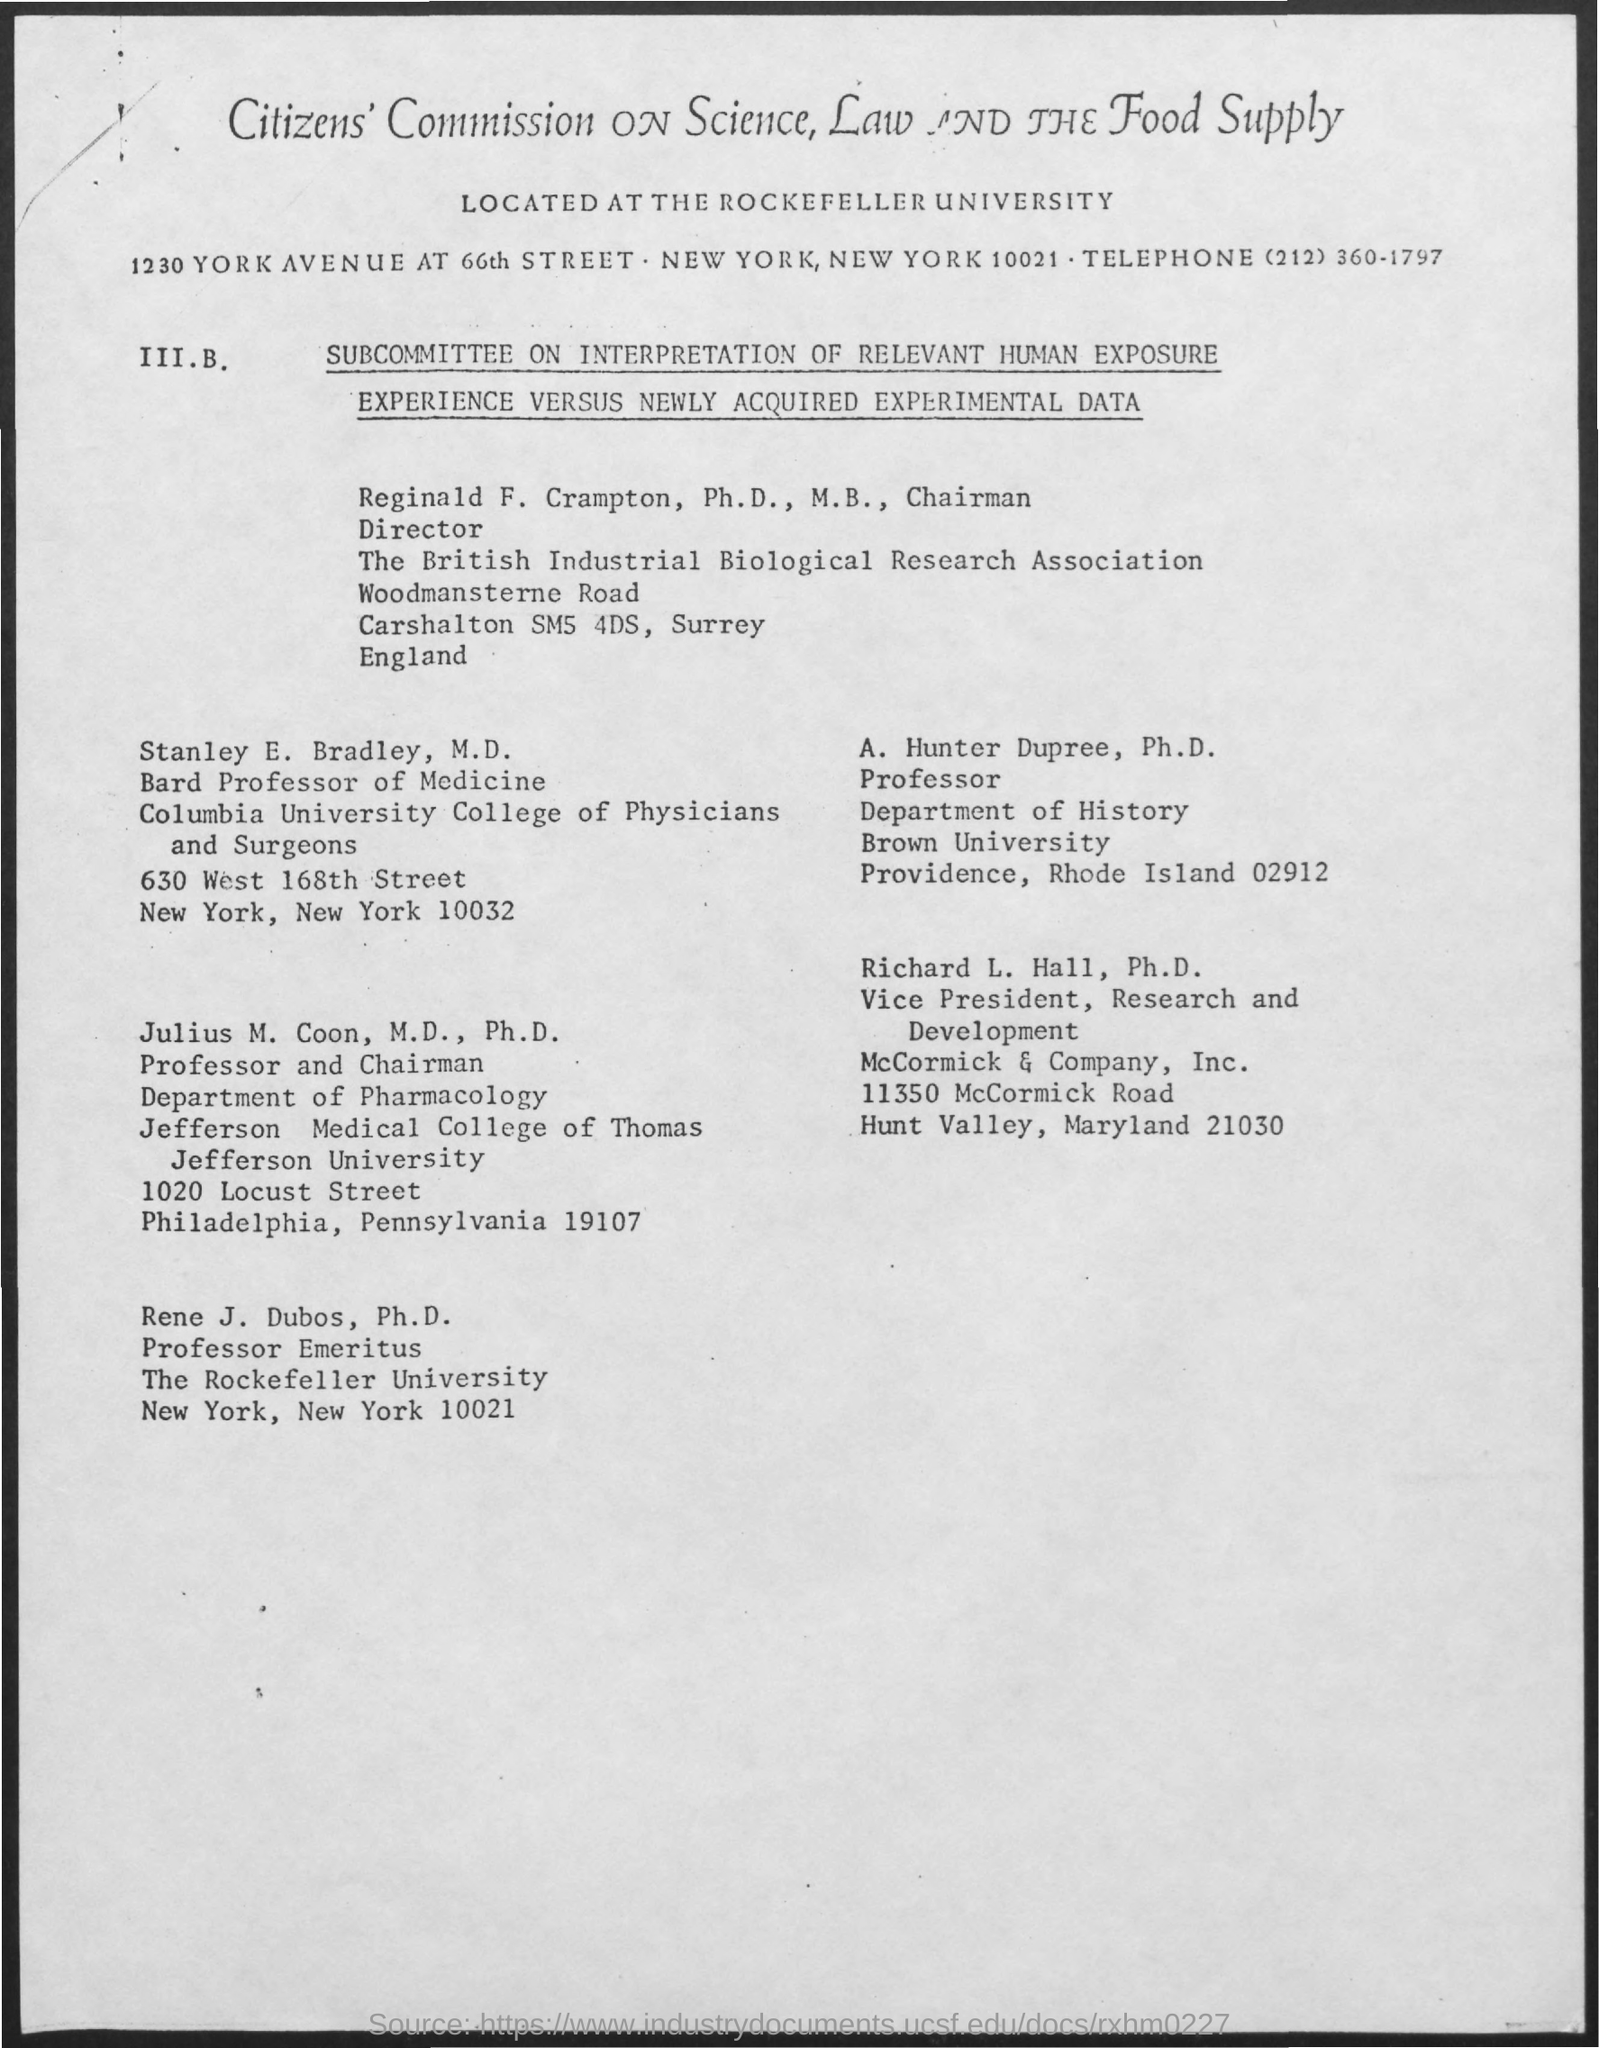Identify some key points in this picture. Hunter Dupree, Ph.D., is the Professor of the Department of History at Brown University. The individual who holds the position of Vice President of Research and Development is named Richard L. Hall. 